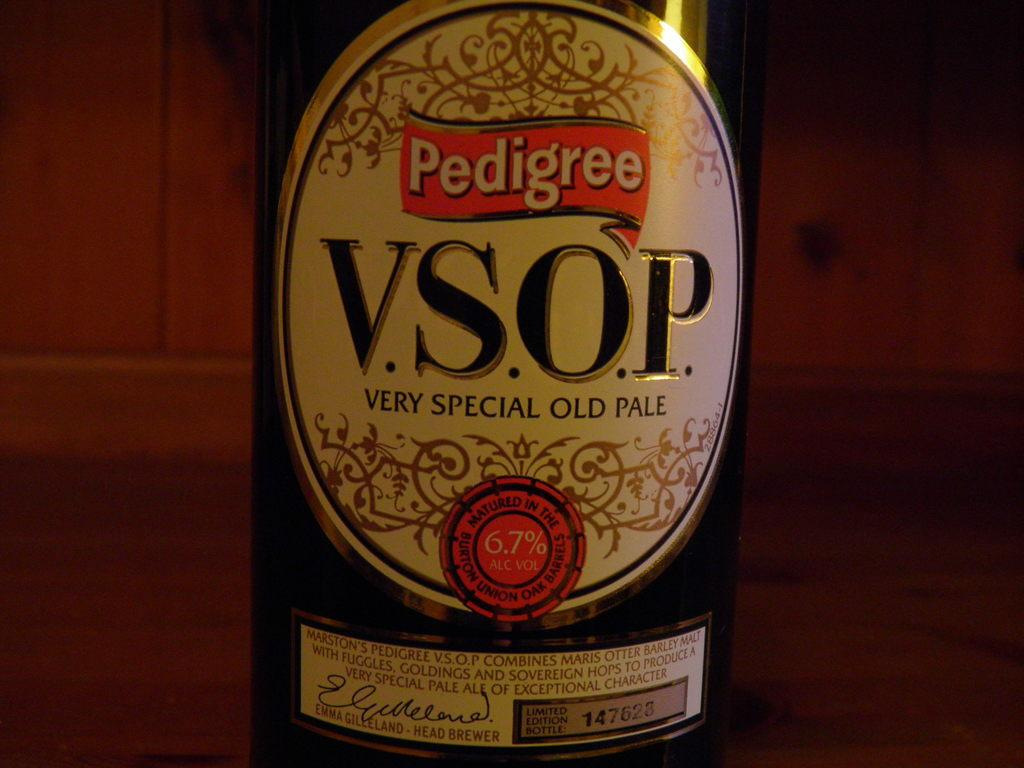<image>
Render a clear and concise summary of the photo. Pedigree is proud to offer a very special old pale also known as V.S.O.P. 